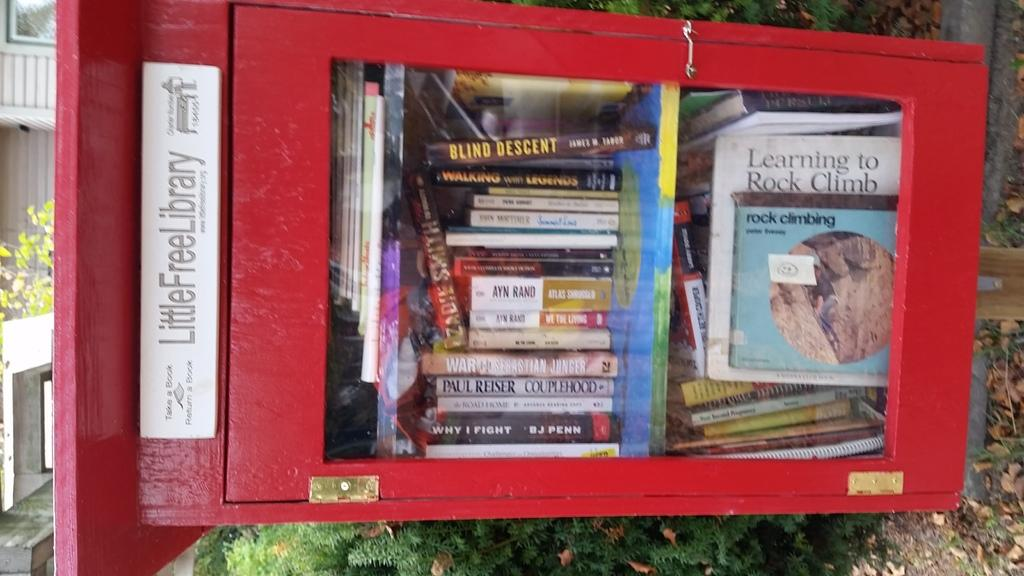<image>
Render a clear and concise summary of the photo. The red box with books is from the program called Little Free Library 